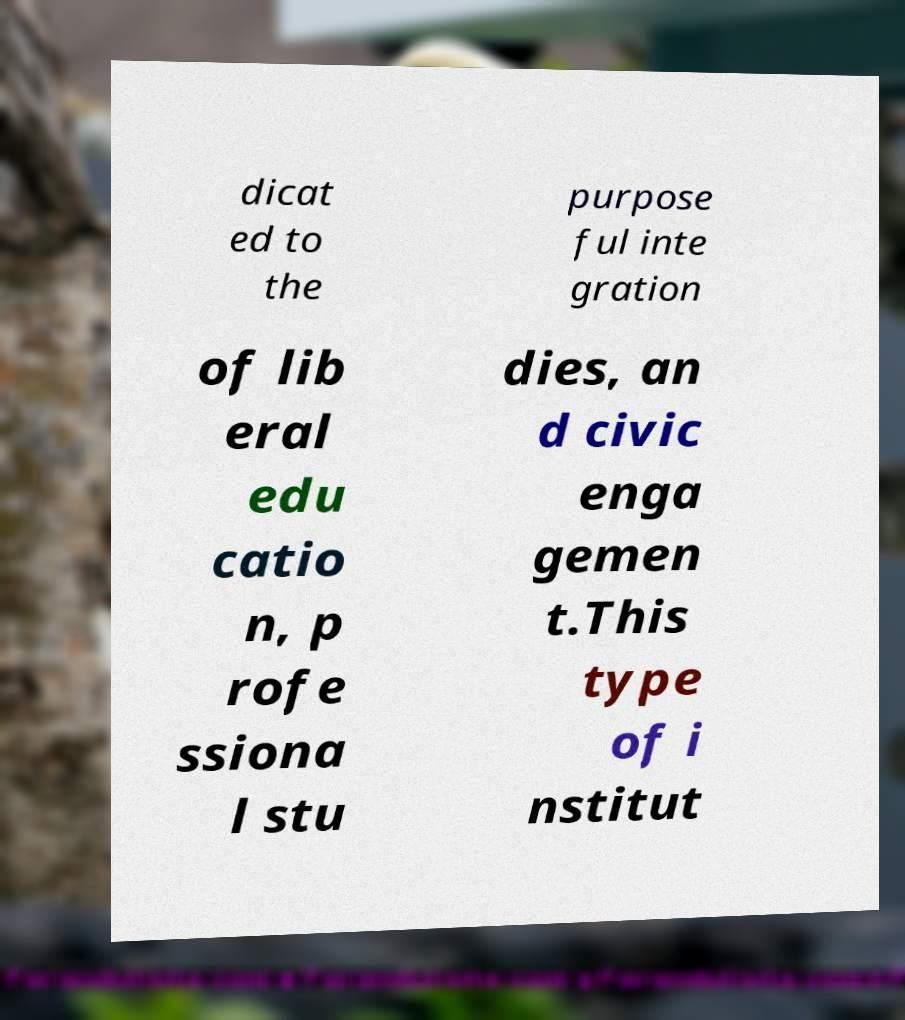I need the written content from this picture converted into text. Can you do that? dicat ed to the purpose ful inte gration of lib eral edu catio n, p rofe ssiona l stu dies, an d civic enga gemen t.This type of i nstitut 